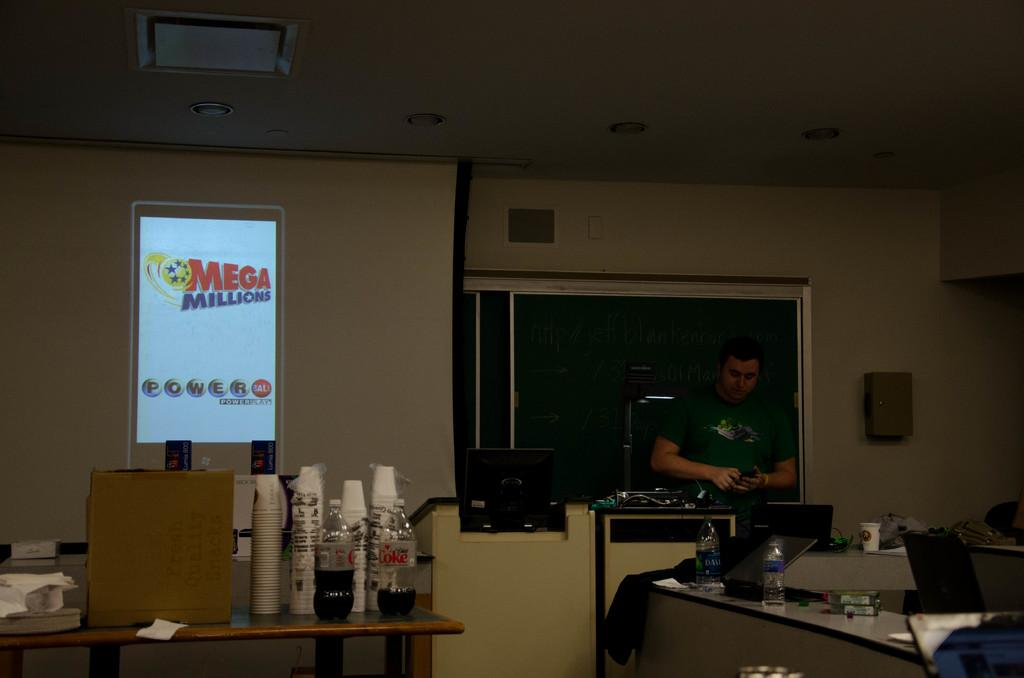<image>
Describe the image concisely. A man stand at a counter with a Mega Millions display next to him. 